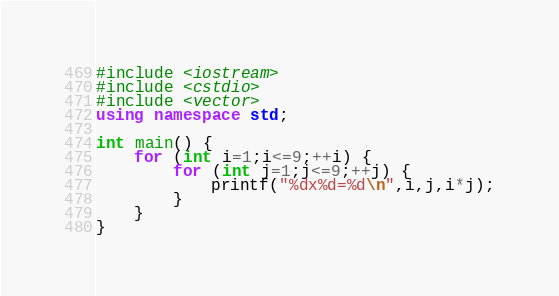Convert code to text. <code><loc_0><loc_0><loc_500><loc_500><_C++_>#include <iostream>
#include <cstdio>
#include <vector>
using namespace std;

int main() {
	for (int i=1;i<=9;++i) {
		for (int j=1;j<=9;++j) {
			printf("%dx%d=%d\n",i,j,i*j);
		}
	}
}</code> 